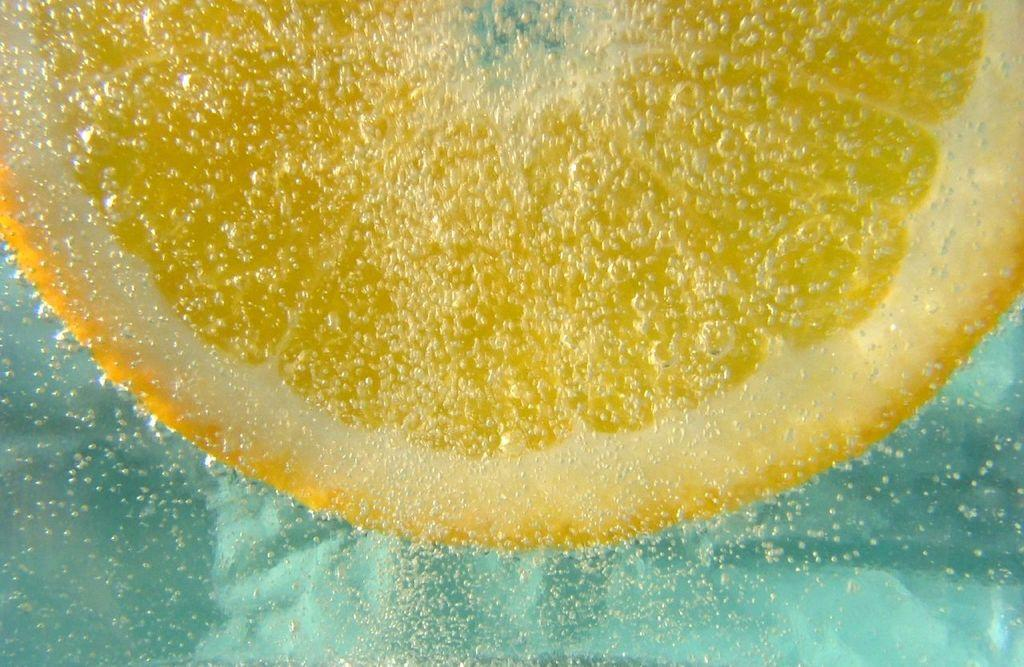What type of fruit is visible in the image? There is a slice of orange in the image. Where is the slice of orange located? The slice of orange is in the water. What is the condition of the appliance in the image? There is no appliance present in the image. Is the orange poisonous in the image? The image does not provide any information about the orange being poisonous or not. 